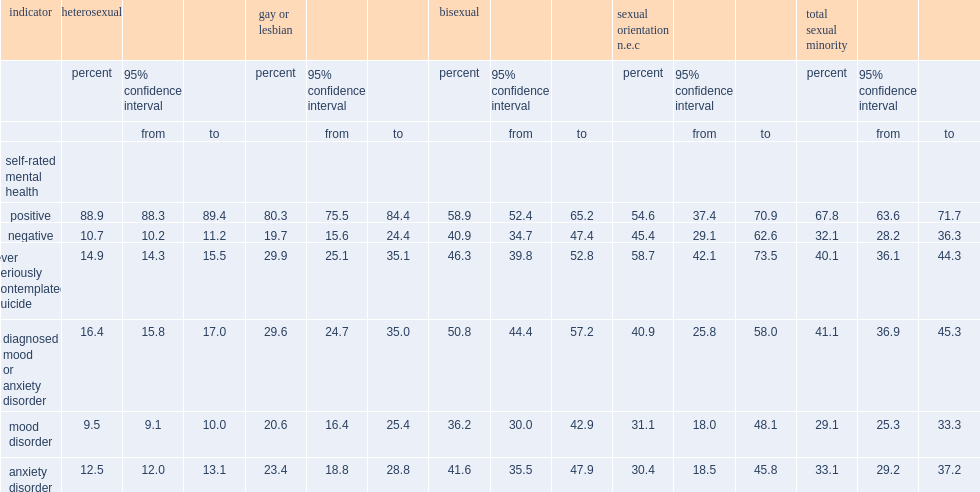How many percent of all sexual minority canadians aged 15 and older have stated that their mental health was poor or fair? 32.1. How many percent of bisexual canadians and gay or lesbian canadians, respectively, have reported poor or fair mental health? 40.9 19.7. How many percent of heterosexual canadians have reported poor or fair mental health? 10.7. How many percent of sexual minority canadians have reported that they had been diagnosed with a mood or anxiety disorder? 41.1. How many percent of heterosexual canadians have reported a mood or anxiety disorder diagnosis. 16.4. Among sexual minorities, how many percent of bisexual canadians have reported they had been diagnosed with a mood or anxiety disorder? 50.8. How many percent of gay or lesbian canadians have reported a diagnosed mood or anxiety disorder? 29.6. How many percent of those who were a sexual minority not elsewhere classified have reported a diagnosed mood or anxiety disorder? 40.9. How many percent of heterosexual canadians have reported that they had seriously contemplated suicide at some point in their lives? 14.9. How many percent of sexual minority canadians have reported that they had seriously contemplated suicide at some point in their lives? 40.1. Whichgroup of people is least likely to report that they had contemplated suicide? Heterosexual. 